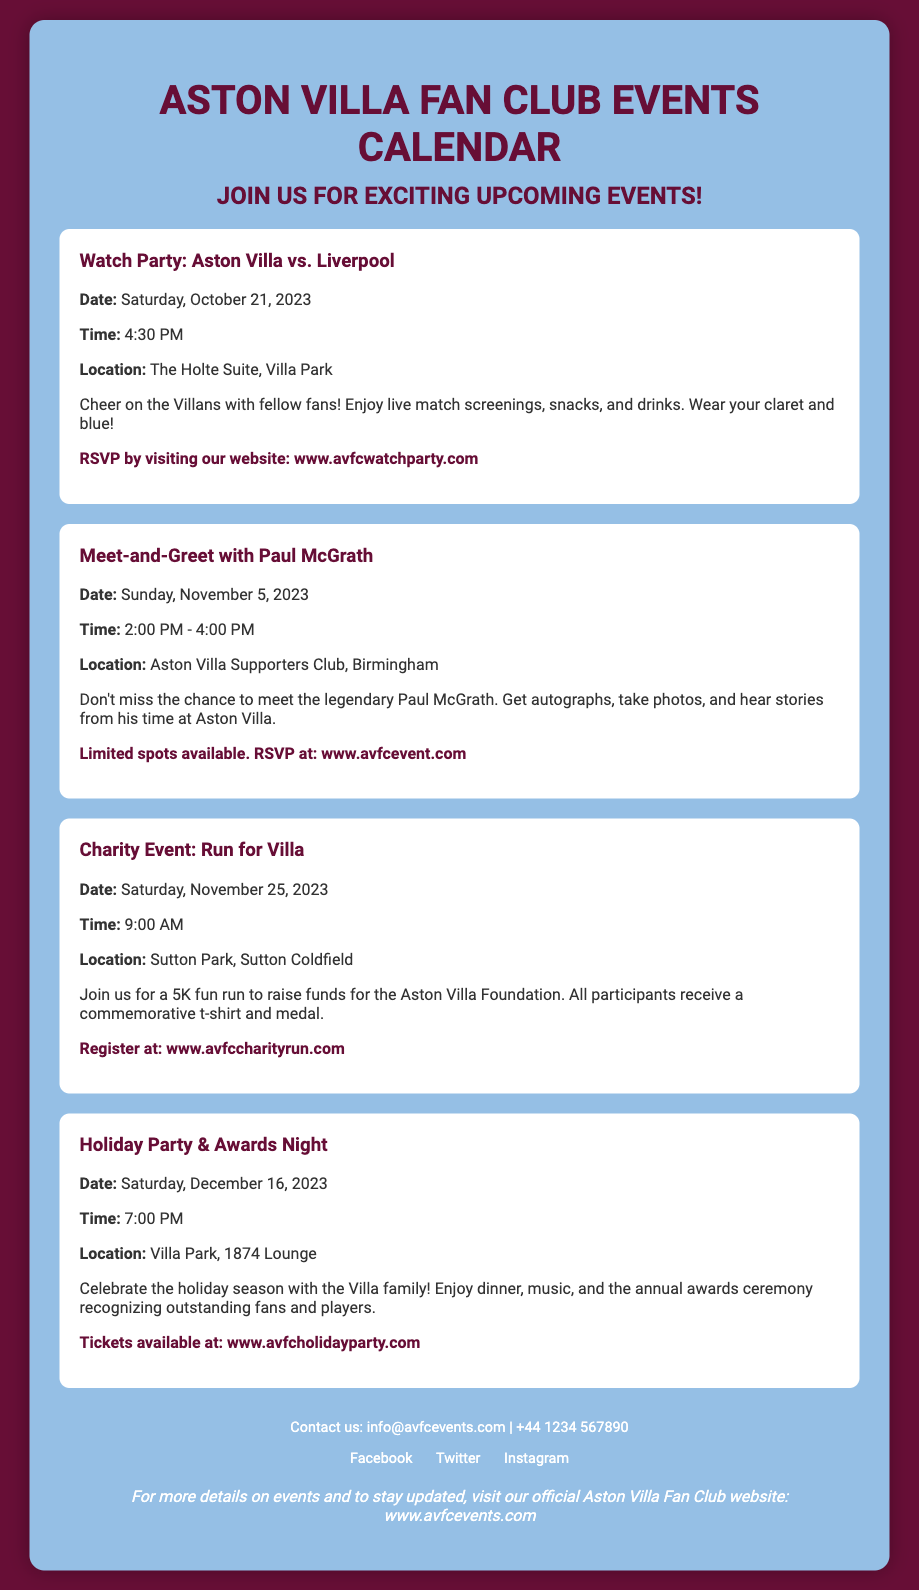What is the date of the watch party? The watch party is scheduled for Saturday, October 21, 2023, as mentioned in the event details.
Answer: Saturday, October 21, 2023 Who is the guest for the meet-and-greet event? The guest for the meet-and-greet event is Paul McGrath, indicated in the event title.
Answer: Paul McGrath What is the location of the charity event? The charity event will take place at Sutton Park, Sutton Coldfield, as stated in the event details.
Answer: Sutton Park, Sutton Coldfield How much time is allocated for the meet-and-greet with Paul McGrath? The meet-and-greet event runs from 2:00 PM to 4:00 PM, indicating a duration of two hours.
Answer: 2 hours What is the registration website for the charity run? The document specifies that participants can register at the website related to the charity run.
Answer: www.avfccharityrun.com What is the main activity at the Holiday Party & Awards Night? The main activity at the Holiday Party & Awards Night includes dinner, music, and an awards ceremony.
Answer: Dinner, music, and awards ceremony How can attendees RSVP for the watch party? The flyer states that attendees can RSVP by visiting the specified website for the watch party.
Answer: www.avfcwatchparty.com What time does the Holiday Party start? The Holiday Party is scheduled to start at 7:00 PM, as mentioned in the event details.
Answer: 7:00 PM What is the theme color used in the document? The theme color prominently used in the document is claret, which is representative of Aston Villa's colors.
Answer: Claret 